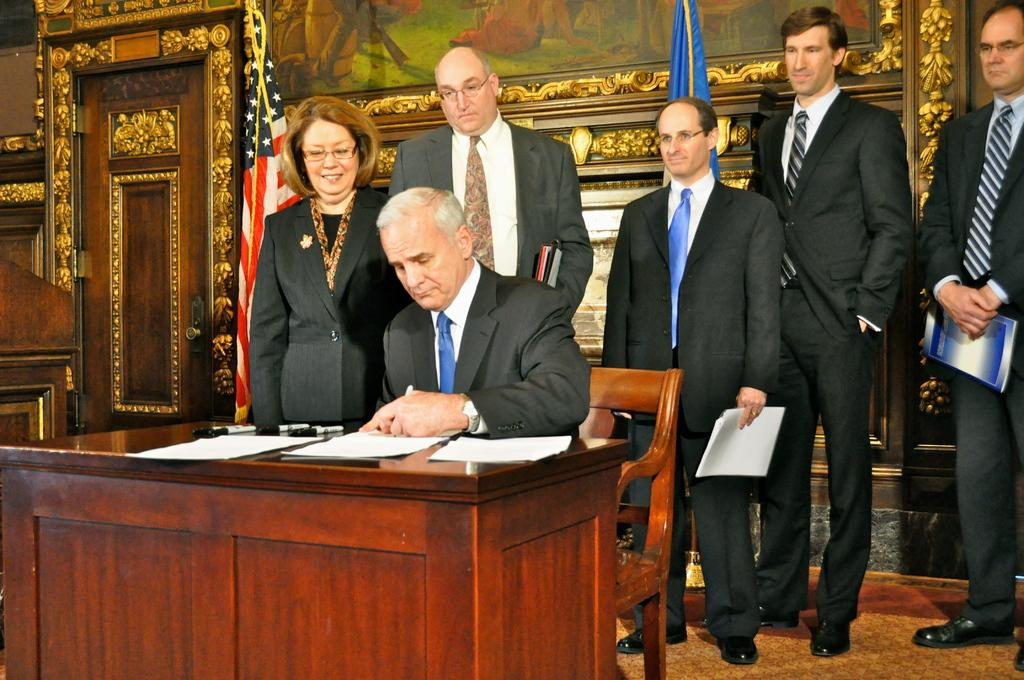What is the man in the image doing? The man is seated on a chair and writing on a paper. Where is the paper located? The paper is on a table. How many people are standing behind the man? There are 5 people standing behind the man. What can be seen in the background of the image? There is a flag visible in the image. What type of wool is the man using to write on the paper? The man is not using wool to write on the paper; he is using a pen or pencil. Who is the owner of the flag in the image? There is no information provided about the ownership of the flag in the image. 